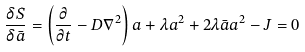Convert formula to latex. <formula><loc_0><loc_0><loc_500><loc_500>\frac { \delta S } { \delta \bar { a } } = \left ( \frac { \partial } { \partial t } - D \nabla ^ { 2 } \right ) a + \lambda a ^ { 2 } + 2 \lambda \bar { a } a ^ { 2 } - J = 0</formula> 